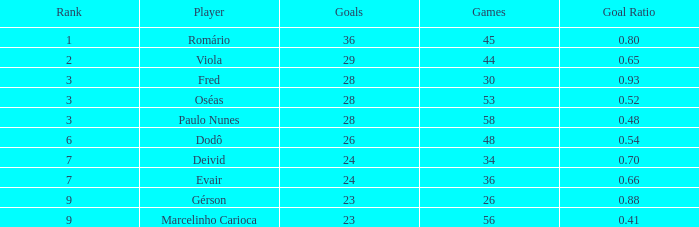What is the largest value for goals in rank over 3 with goal ration of 0.54? 26.0. 